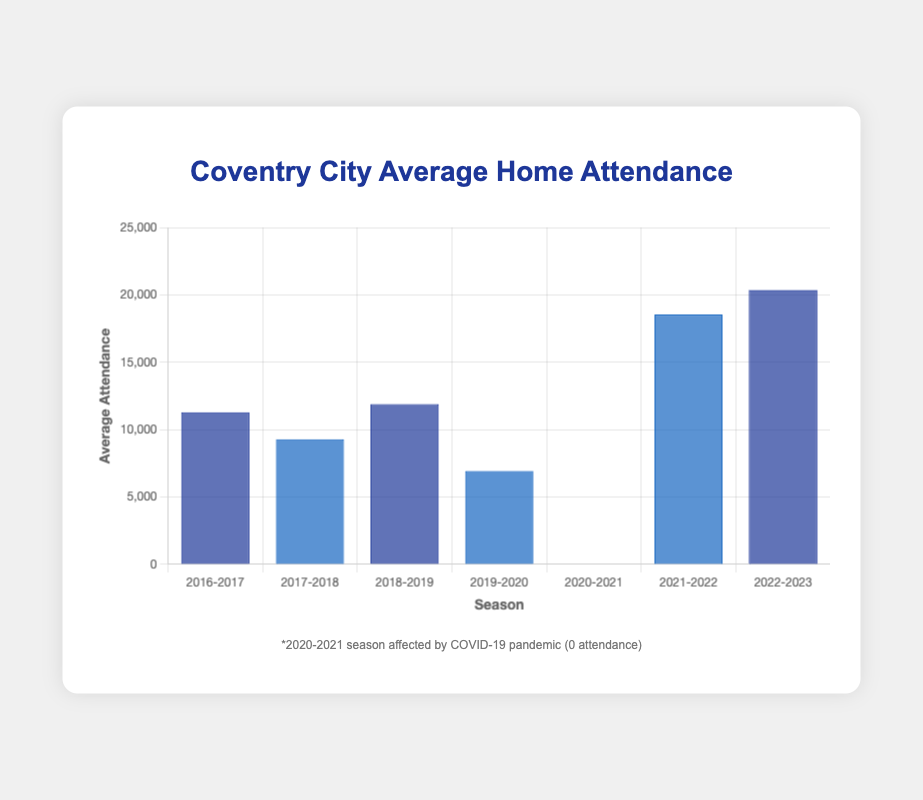What is the average attendance during the 2021-2022 season? To find this, look directly at the bar corresponding to the 2021-2022 season and read the value. The bar height represents the average attendance figure.
Answer: 18,547 Which season had the highest average attendance? Compare the heights of all the bars and identify the tallest one. The tallest bar corresponds to the season with the highest average attendance.
Answer: 2022-2023 How did the average attendance change between the 2016-2017 and 2017-2018 seasons? Subtract the average attendance of the 2017-2018 season from that of the 2016-2017 season.
Answer: It decreased by 2,005 What is the total average attendance over the Championship seasons shown? Sum the average attendances of the seasons where the team was in the Championship. Specifically, add the values for the 2020-2021, 2021-2022, and 2022-2023 seasons.
Answer: 38,901 By how much did the average attendance increase from the 2019-2020 season to the 2022-2023 season? Subtract the average attendance of the 2019-2020 season from that of the 2022-2023 season.
Answer: 13,420 Which seasons had an average attendance of less than 10,000? Examine the heights of the bars and identify those that fall below the 10,000 mark on the y-axis.
Answer: 2017-2018, 2019-2020, 2020-2021 How many seasons had an average attendance greater than 15,000? Count the number of bars that exceed the 15,000 mark on the y-axis.
Answer: 3 What was the impact of the COVID-19 pandemic on average attendance? Locate the bar for the 2020-2021 season and observe the value. It’s mentioned there was zero attendance due to the COVID-19 pandemic.
Answer: 0 attendance Compare the average attendances between the League Two and Championship status seasons. What can you observe? Check the bars corresponding to the League Two season and sum them up (only 2017-2018 for League Two), then sum the bars for Championship seasons (2020-2021, 2021-2022, 2022-2023). Compare the two sums.
Answer: Championship seasons had higher attendance What was the trend in average attendance from the 2017-2018 to the 2022-2023 seasons? Track the increasing or decreasing pattern in the heights of the bars from 2017-2018 through to 2022-2023, noting any significant changes.
Answer: Generally increasing, with a significant dip during the pandemic 